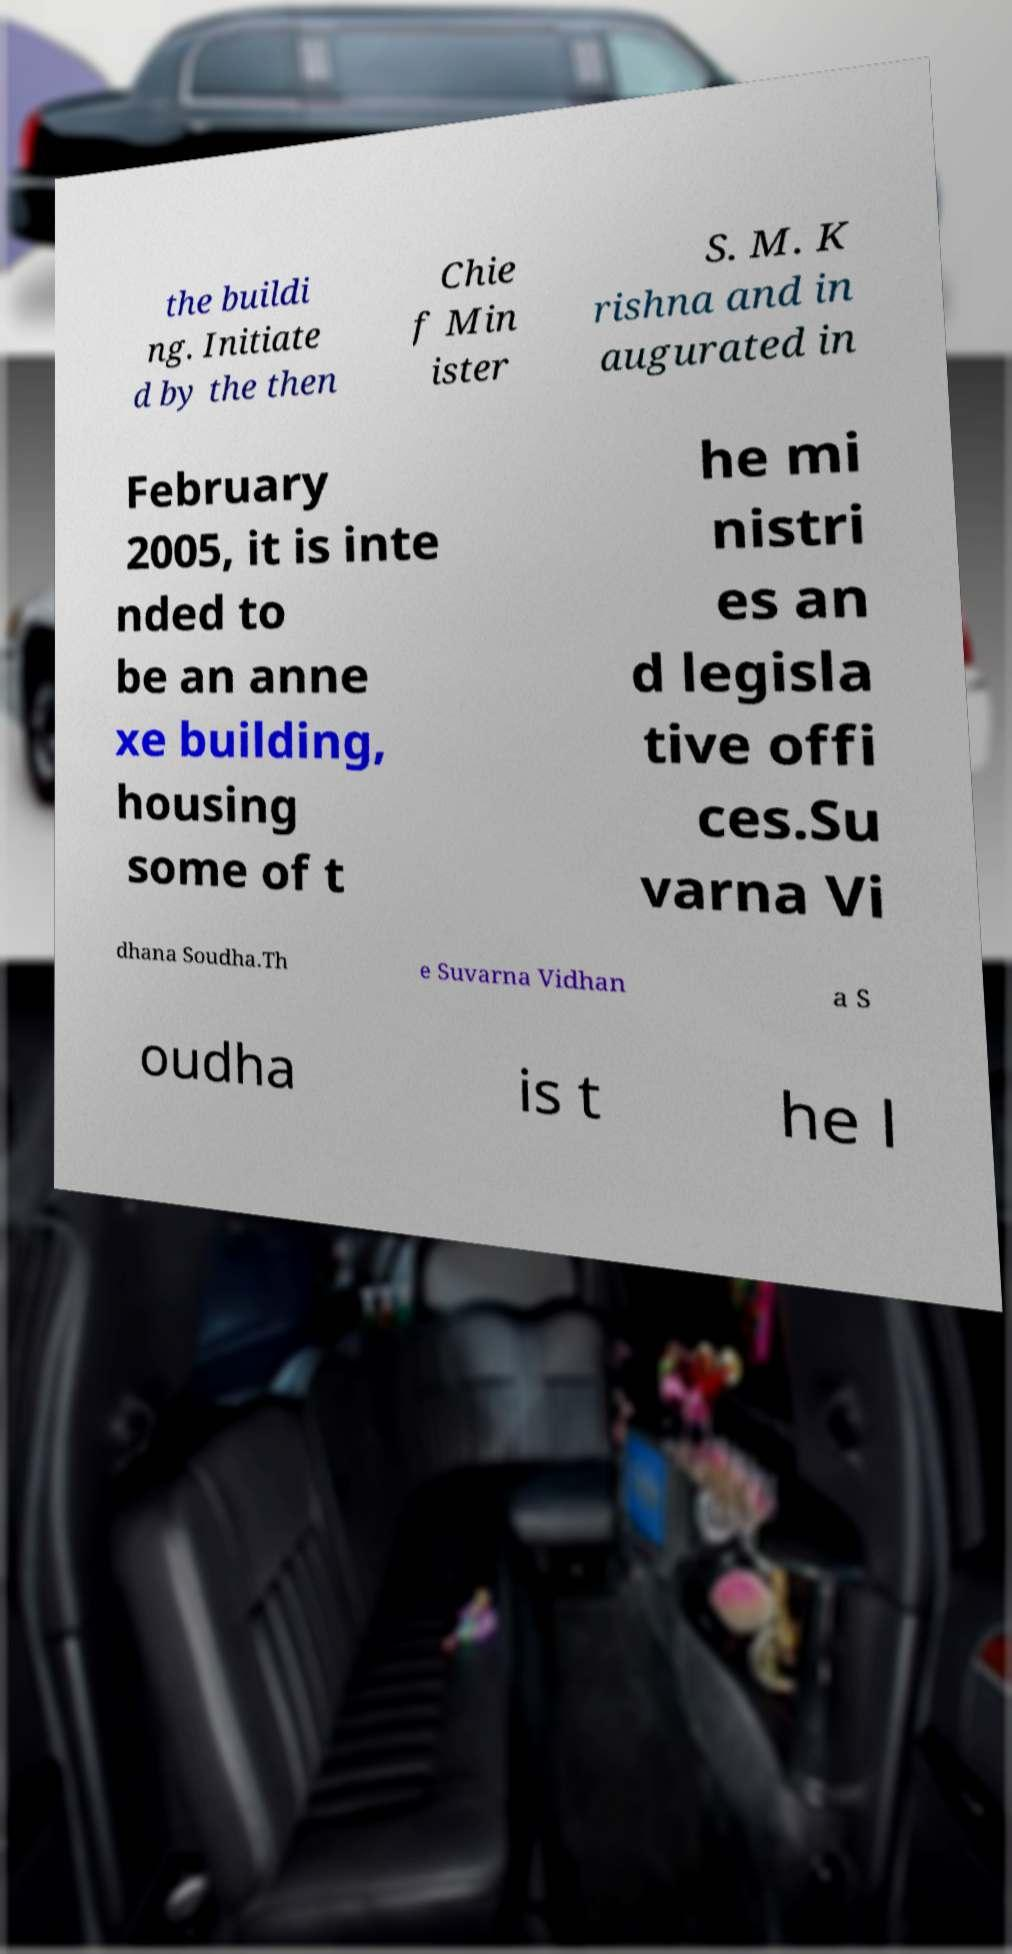I need the written content from this picture converted into text. Can you do that? the buildi ng. Initiate d by the then Chie f Min ister S. M. K rishna and in augurated in February 2005, it is inte nded to be an anne xe building, housing some of t he mi nistri es an d legisla tive offi ces.Su varna Vi dhana Soudha.Th e Suvarna Vidhan a S oudha is t he l 